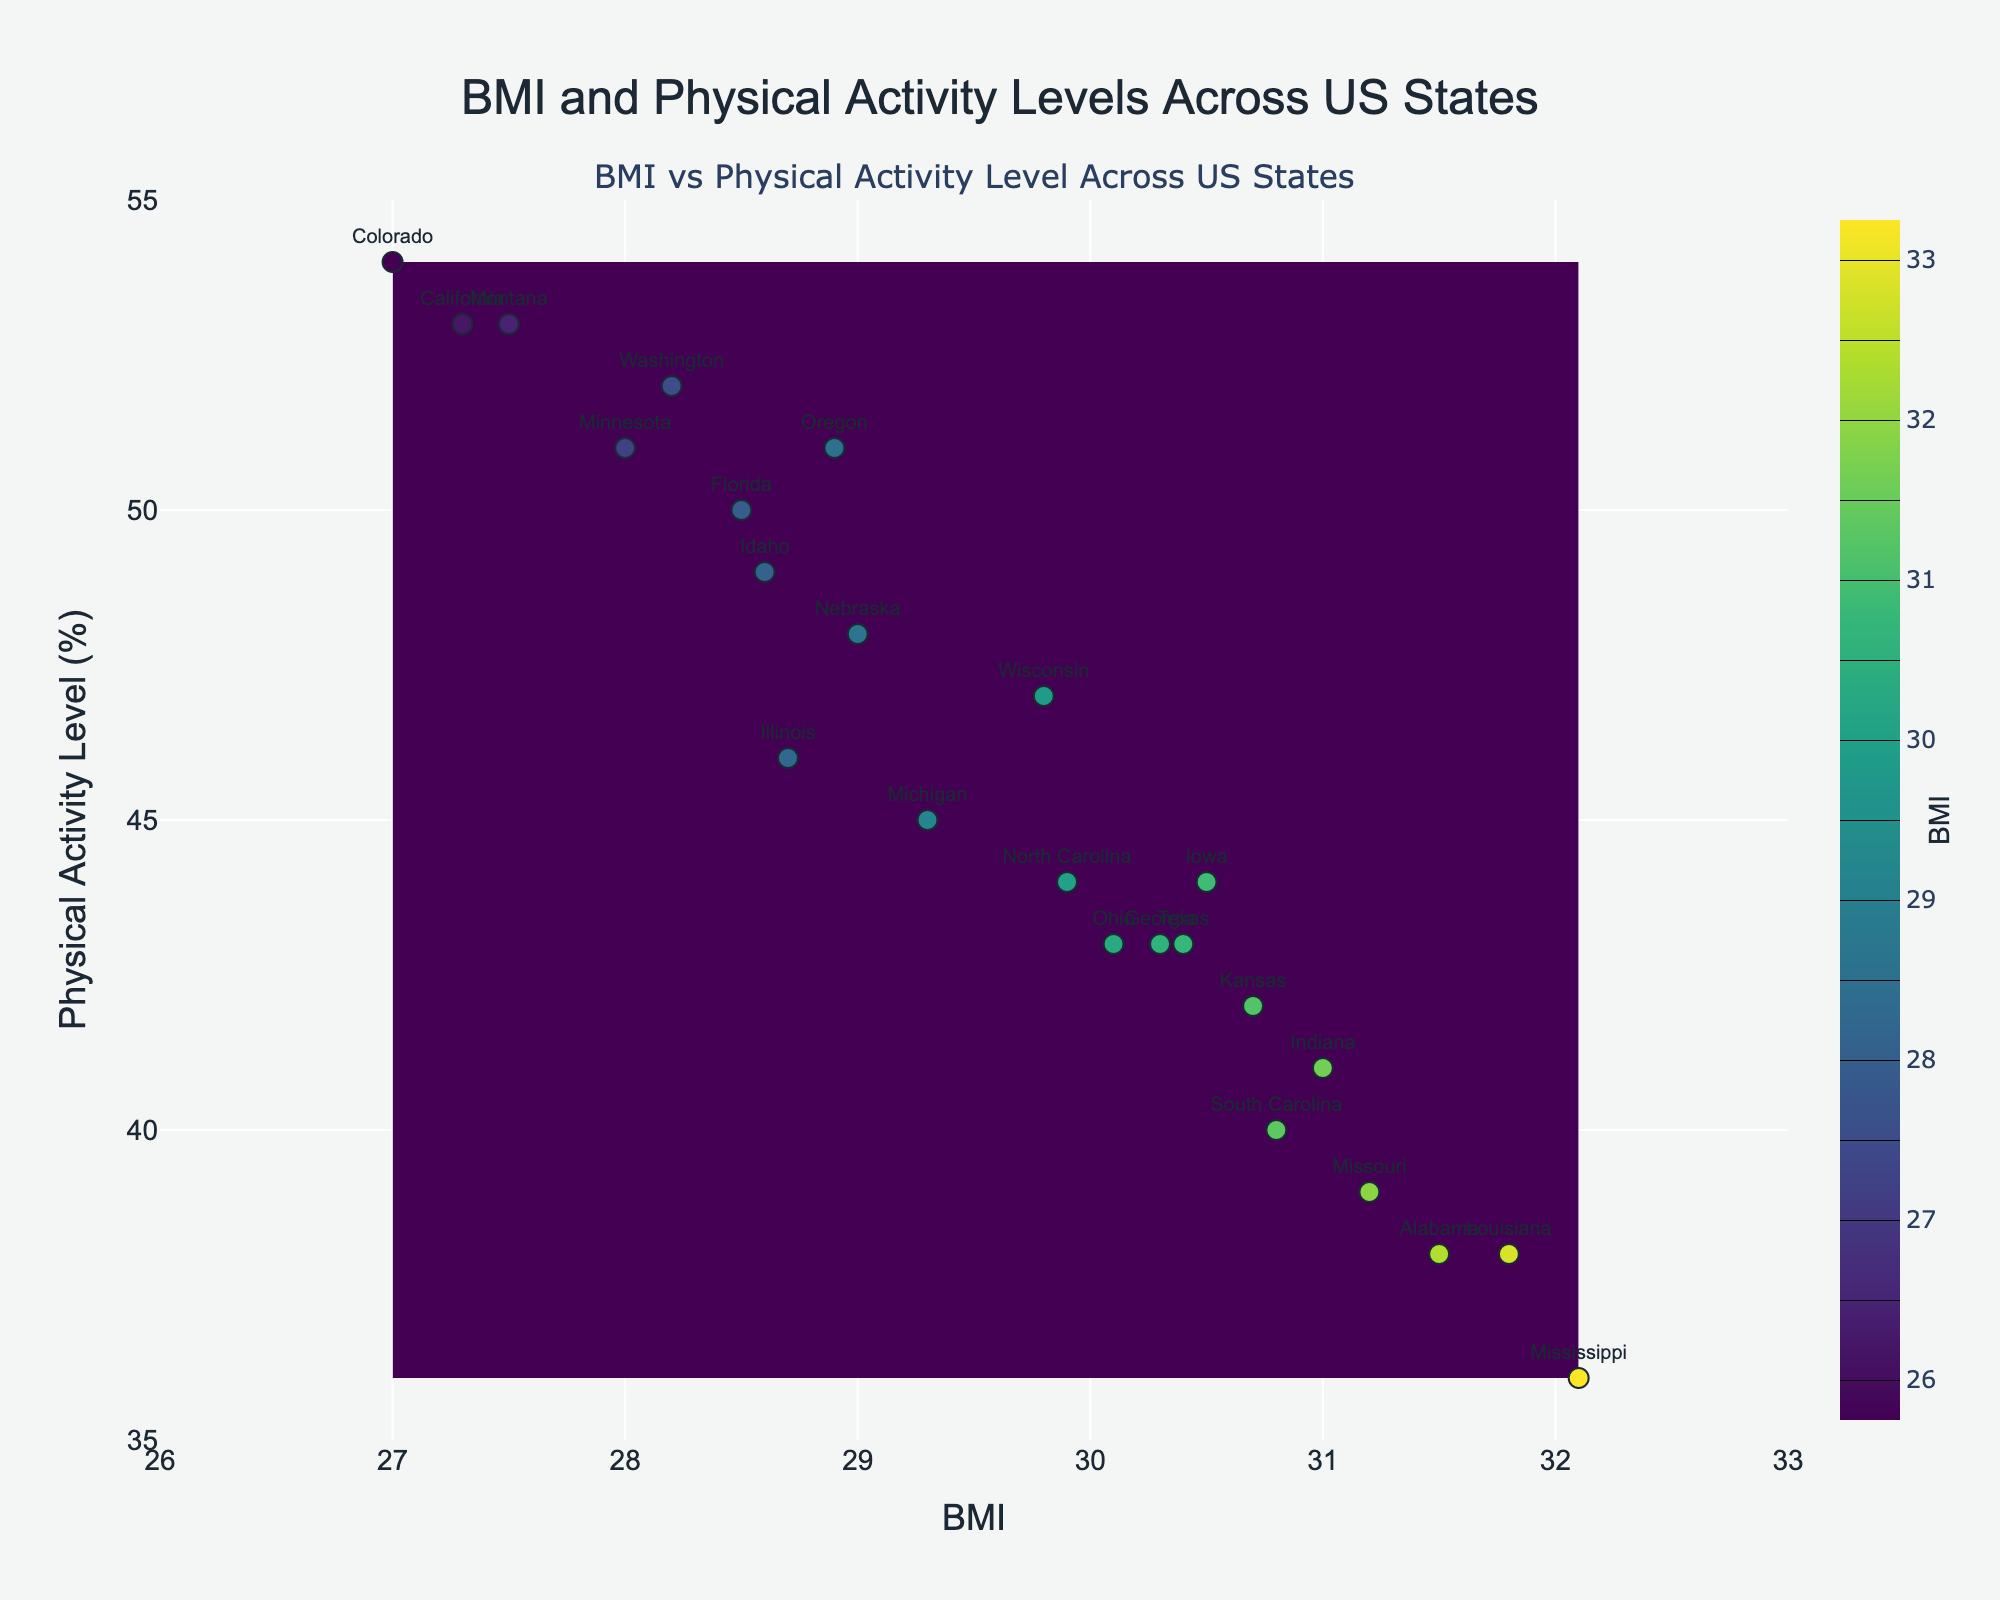What is the range of BMI values displayed on the x-axis? Look at the x-axis of the plot; the minimum value is 26 and the maximum value is 33.
Answer: 26 to 33 Which state has the highest BMI? Observe the scatter plot; the state with the highest BMI is labeled. Mississippi has the highest BMI at 32.1.
Answer: Mississippi Which state has the lowest physical activity level? Look at the y-axis values for each scatter point; the state with the lowest physical activity level is labeled. Mississippi also has the lowest physical activity level at 36.
Answer: Mississippi How many states have a physical activity level of 50% or higher? Count the number of data points above the 50% mark on the y-axis. The states are Florida, California, Washington, Oregon, Colorado, Idaho, and Montana, totaling 7.
Answer: 7 Which state has the lowest BMI and what is its physical activity level? According to the scatter plot, Colorado has the lowest BMI at 27.0. Its physical activity level is 54%.
Answer: Colorado, 54% What is the relationship between BMI and physical activity levels as observed in the plot? Generally, observe the scatter pattern; states with lower BMIs tend to have higher physical activity levels, indicating a negative correlation between BMI and physical activity level.
Answer: Negative correlation Which state is closest to the BMI value of 30 and physical activity level of 43%? Identify the scatter point closest to (30, 43). Ohio, with a BMI of 30.1 and a physical activity level of 43, is the closest.
Answer: Ohio Do any states fall within a BMI range of 28 to 30 and a physical activity level range of 45% to 50%? Name them. Look at the scatter points within the specified ranges on both axes. Illinois, Wisconsin, and Nebraska meet these criteria.
Answer: Illinois, Wisconsin, Nebraska Which states are labeled in the highest contour band (indicating the highest BMI)? Check the states located towards the darkest or highest contour band in the heatmap. Mississippi, Louisiana, and Alabama fall in this region with BMIs above 31.5.
Answer: Mississippi, Louisiana, Alabama Considering only the states with a physical activity level above 50%, what is the average BMI? Identify states with physical activity levels above 50% (Florida, California, Washington, Oregon, Colorado, Montana). Sum of BMIs for these states is 27.5 + 27.3 + 28.2 + 28.9 + 27.0 + 27.5 = 166.4. Divide by the number of such states (6). The average BMI is 166.4/6 ≈ 27.73.
Answer: ~27.73 